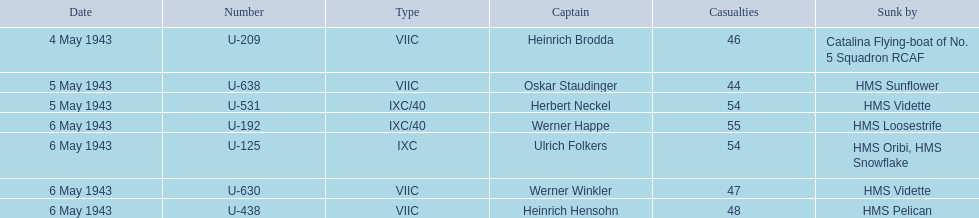Give me the full table as a dictionary. {'header': ['Date', 'Number', 'Type', 'Captain', 'Casualties', 'Sunk by'], 'rows': [['4 May 1943', 'U-209', 'VIIC', 'Heinrich Brodda', '46', 'Catalina Flying-boat of No. 5 Squadron RCAF'], ['5 May 1943', 'U-638', 'VIIC', 'Oskar Staudinger', '44', 'HMS Sunflower'], ['5 May 1943', 'U-531', 'IXC/40', 'Herbert Neckel', '54', 'HMS Vidette'], ['6 May 1943', 'U-192', 'IXC/40', 'Werner Happe', '55', 'HMS Loosestrife'], ['6 May 1943', 'U-125', 'IXC', 'Ulrich Folkers', '54', 'HMS Oribi, HMS Snowflake'], ['6 May 1943', 'U-630', 'VIIC', 'Werner Winkler', '47', 'HMS Vidette'], ['6 May 1943', 'U-438', 'VIIC', 'Heinrich Hensohn', '48', 'HMS Pelican']]} Who are all the leaders? Heinrich Brodda, Oskar Staudinger, Herbert Neckel, Werner Happe, Ulrich Folkers, Werner Winkler, Heinrich Hensohn. What caused the sinking of each leader? Catalina Flying-boat of No. 5 Squadron RCAF, HMS Sunflower, HMS Vidette, HMS Loosestrife, HMS Oribi, HMS Snowflake, HMS Vidette, HMS Pelican. Which one was sunk by the hms pelican? Heinrich Hensohn. 